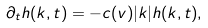Convert formula to latex. <formula><loc_0><loc_0><loc_500><loc_500>\partial _ { t } h ( k , t ) = - c ( v ) | k | h ( k , t ) ,</formula> 